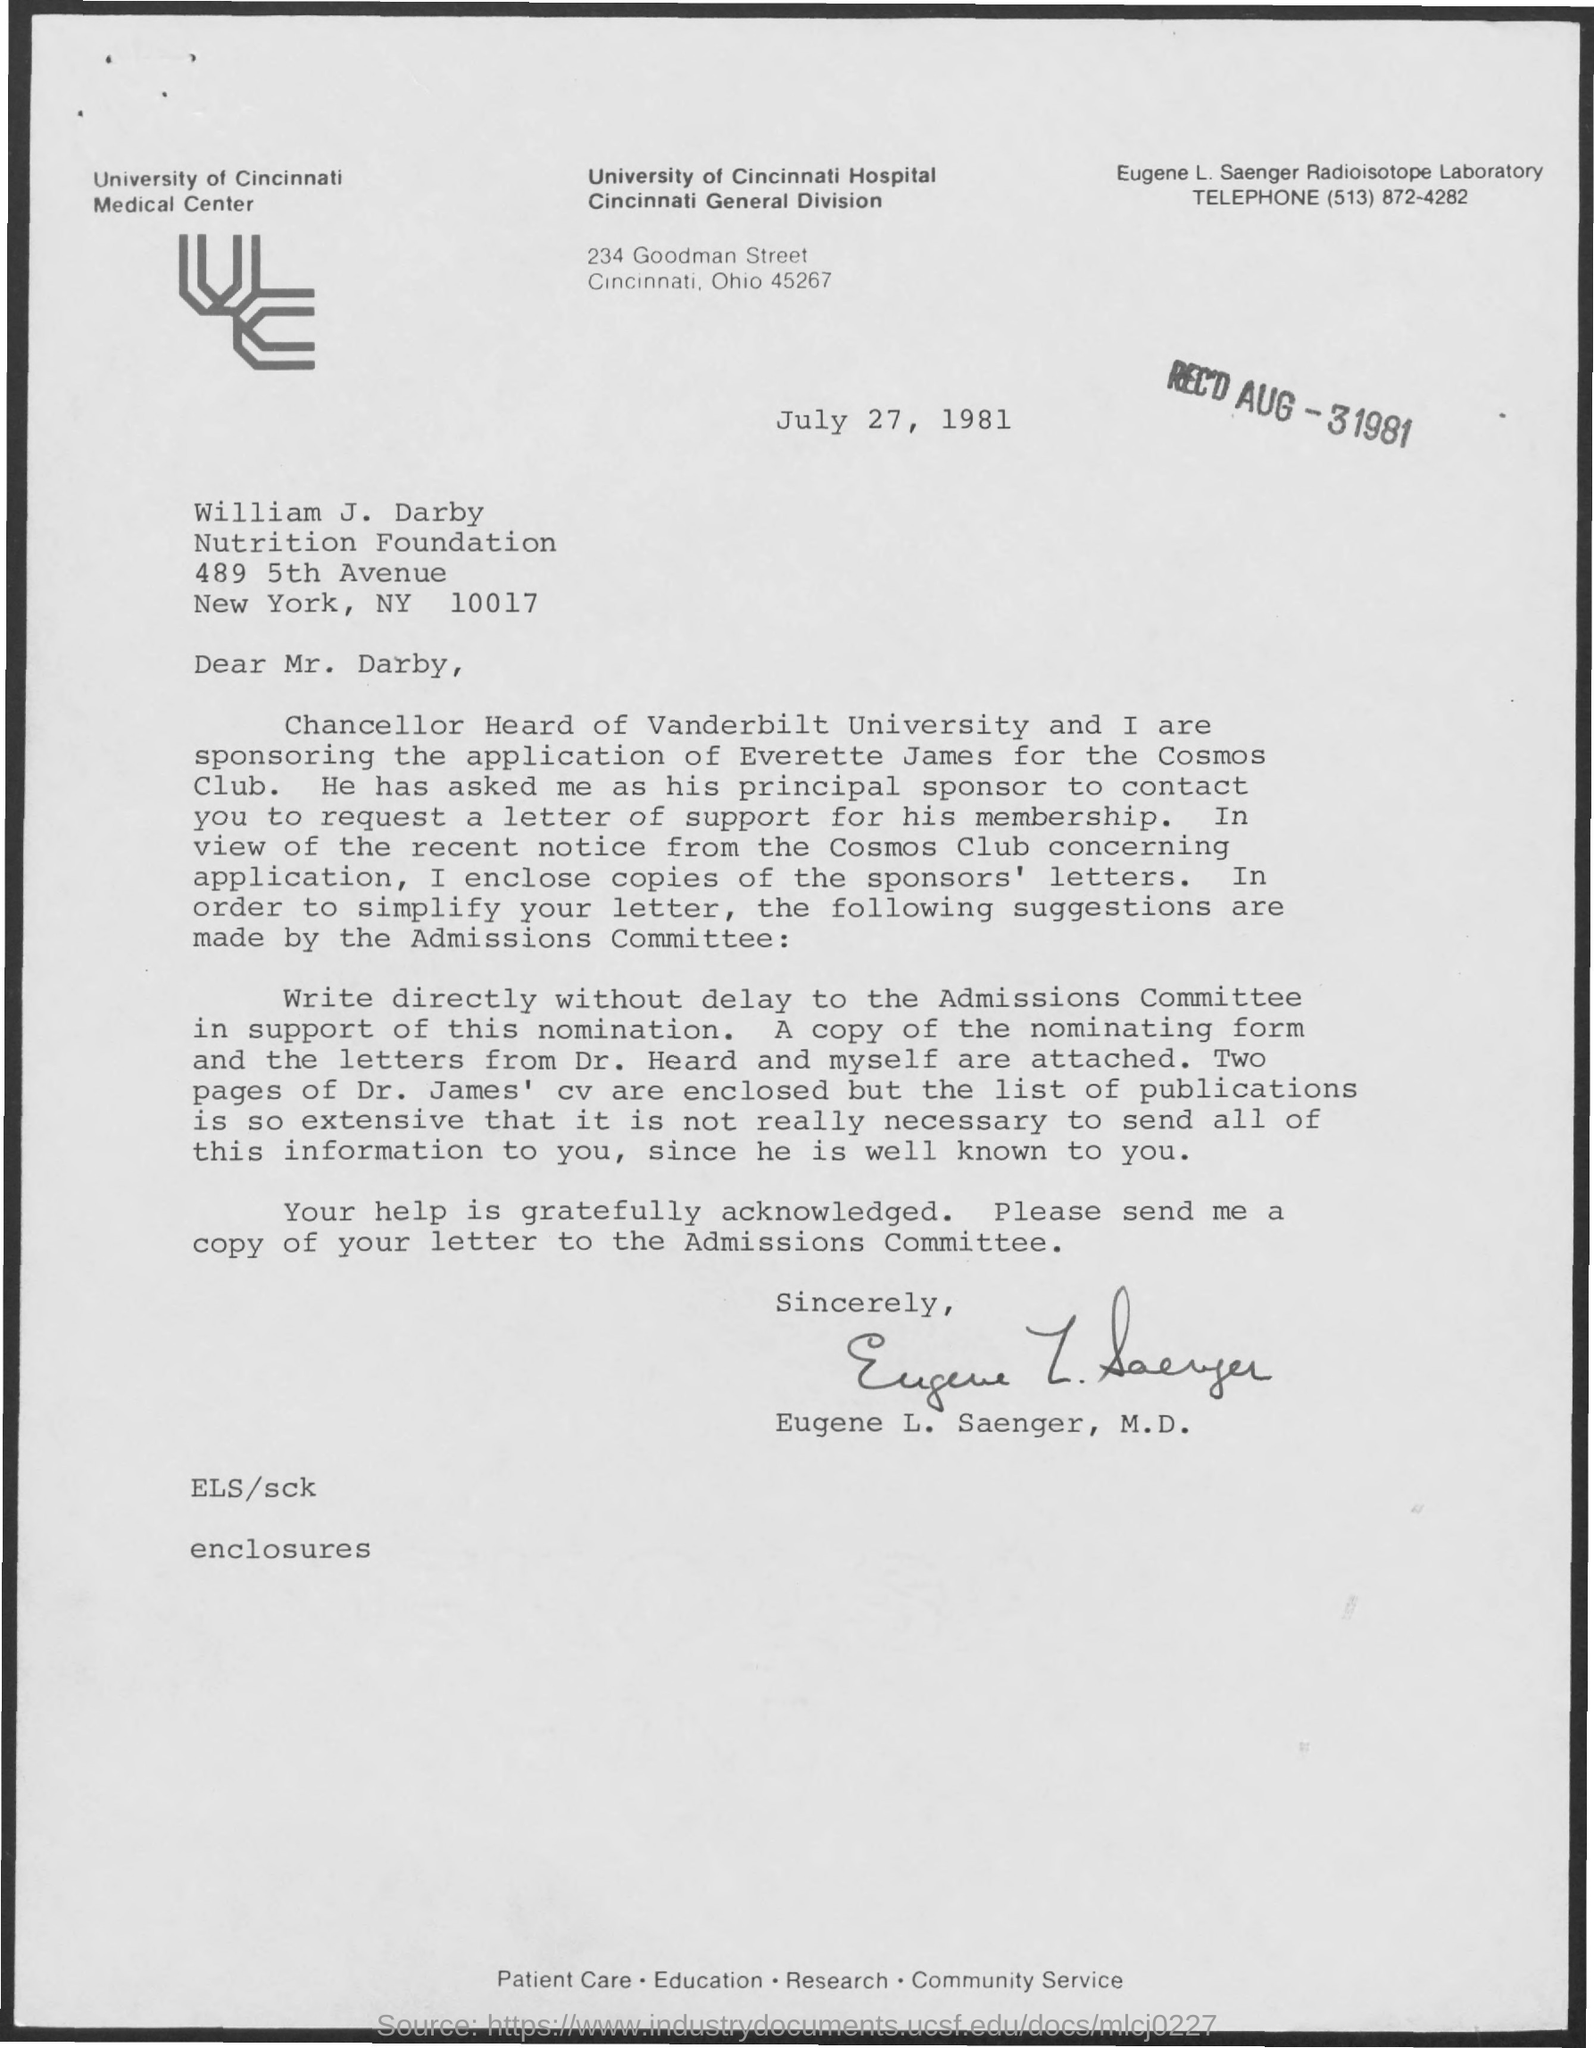Outline some significant characteristics in this image. The University of Cincinnati Hospital is located in Cincinnati, Ohio. The person to whom this letter is written is William J. Darby. July 27, 1981 is the date mentioned. The name of the university is the University of Cincinnati. The date mentioned is August 3, 1981. 